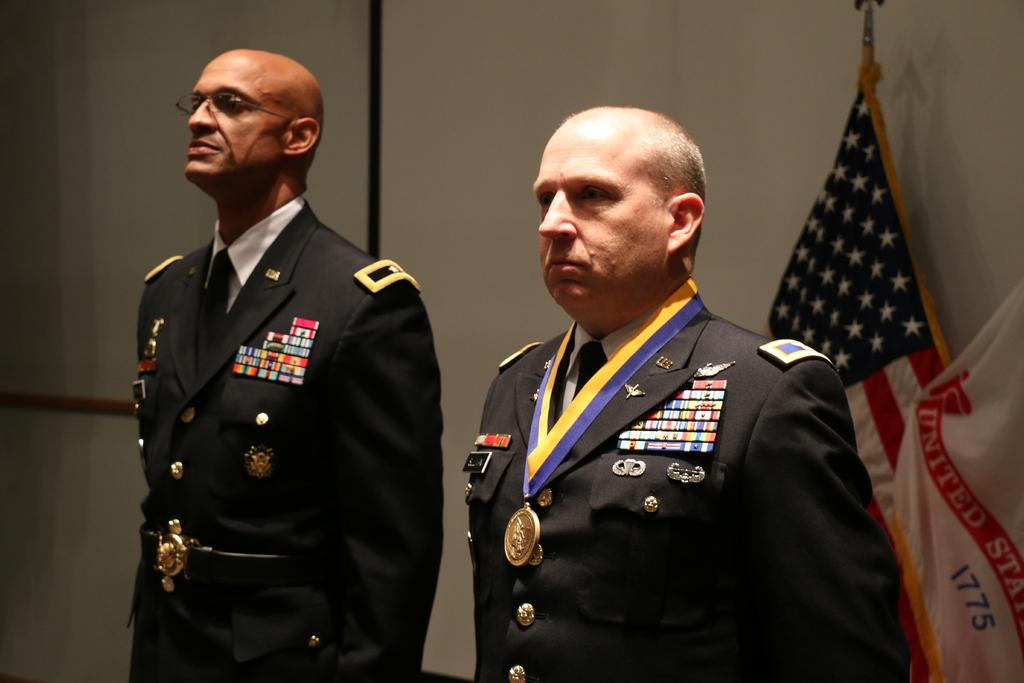How many people are present in the image? There are two people in the image. What can be seen in the background of the image? There are flags and a wall in the background of the image. What type of sweater is the stone wearing in the image? There is no stone or sweater present in the image. How does the digestion process of the people in the image compare to that of a lion? The image does not provide any information about the digestion process of the people, nor does it include any lions for comparison. 